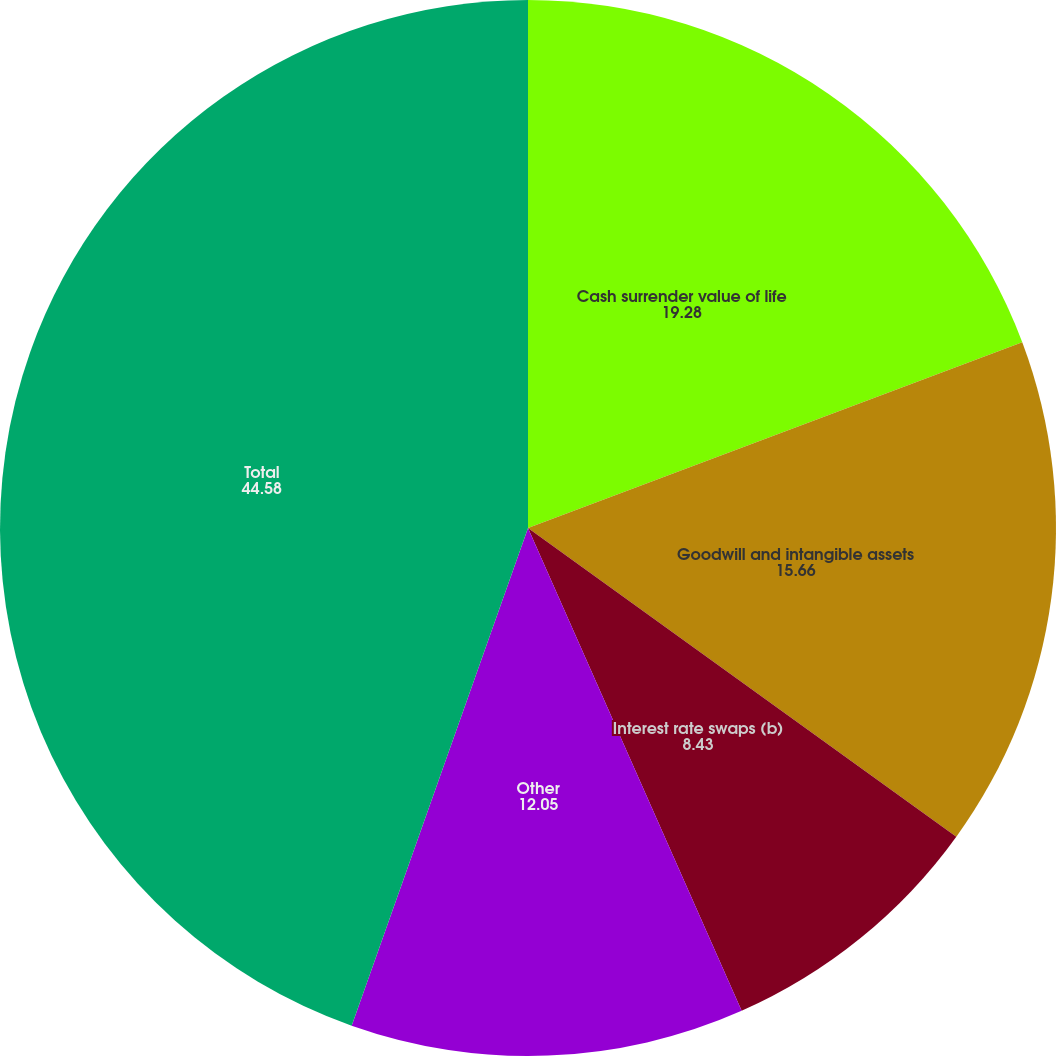Convert chart to OTSL. <chart><loc_0><loc_0><loc_500><loc_500><pie_chart><fcel>Cash surrender value of life<fcel>Goodwill and intangible assets<fcel>Interest rate swaps (b)<fcel>Other<fcel>Total<nl><fcel>19.28%<fcel>15.66%<fcel>8.43%<fcel>12.05%<fcel>44.58%<nl></chart> 